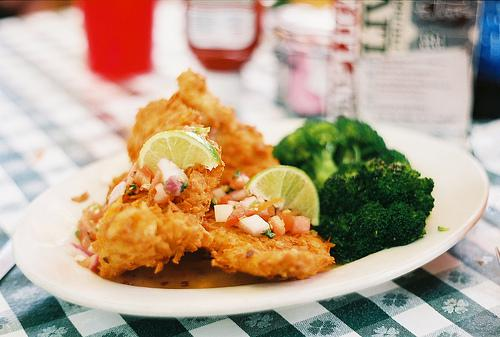Question: what is on the plate?
Choices:
A. Dirt.
B. Chicken.
C. Green beans.
D. Food.
Answer with the letter. Answer: D Question: what is the plate sitting on?
Choices:
A. A table.
B. Counter.
C. Fridge.
D. Microwave.
Answer with the letter. Answer: A Question: what color is the table linen?
Choices:
A. Red and blue.
B. Black and gray.
C. Pink and purple.
D. White and green.
Answer with the letter. Answer: D Question: how is the meat cooked on the plate?
Choices:
A. Fried.
B. Broiled.
C. Boiled.
D. Baked.
Answer with the letter. Answer: A Question: how many limes are there?
Choices:
A. Three.
B. Four.
C. Five.
D. Two.
Answer with the letter. Answer: D 